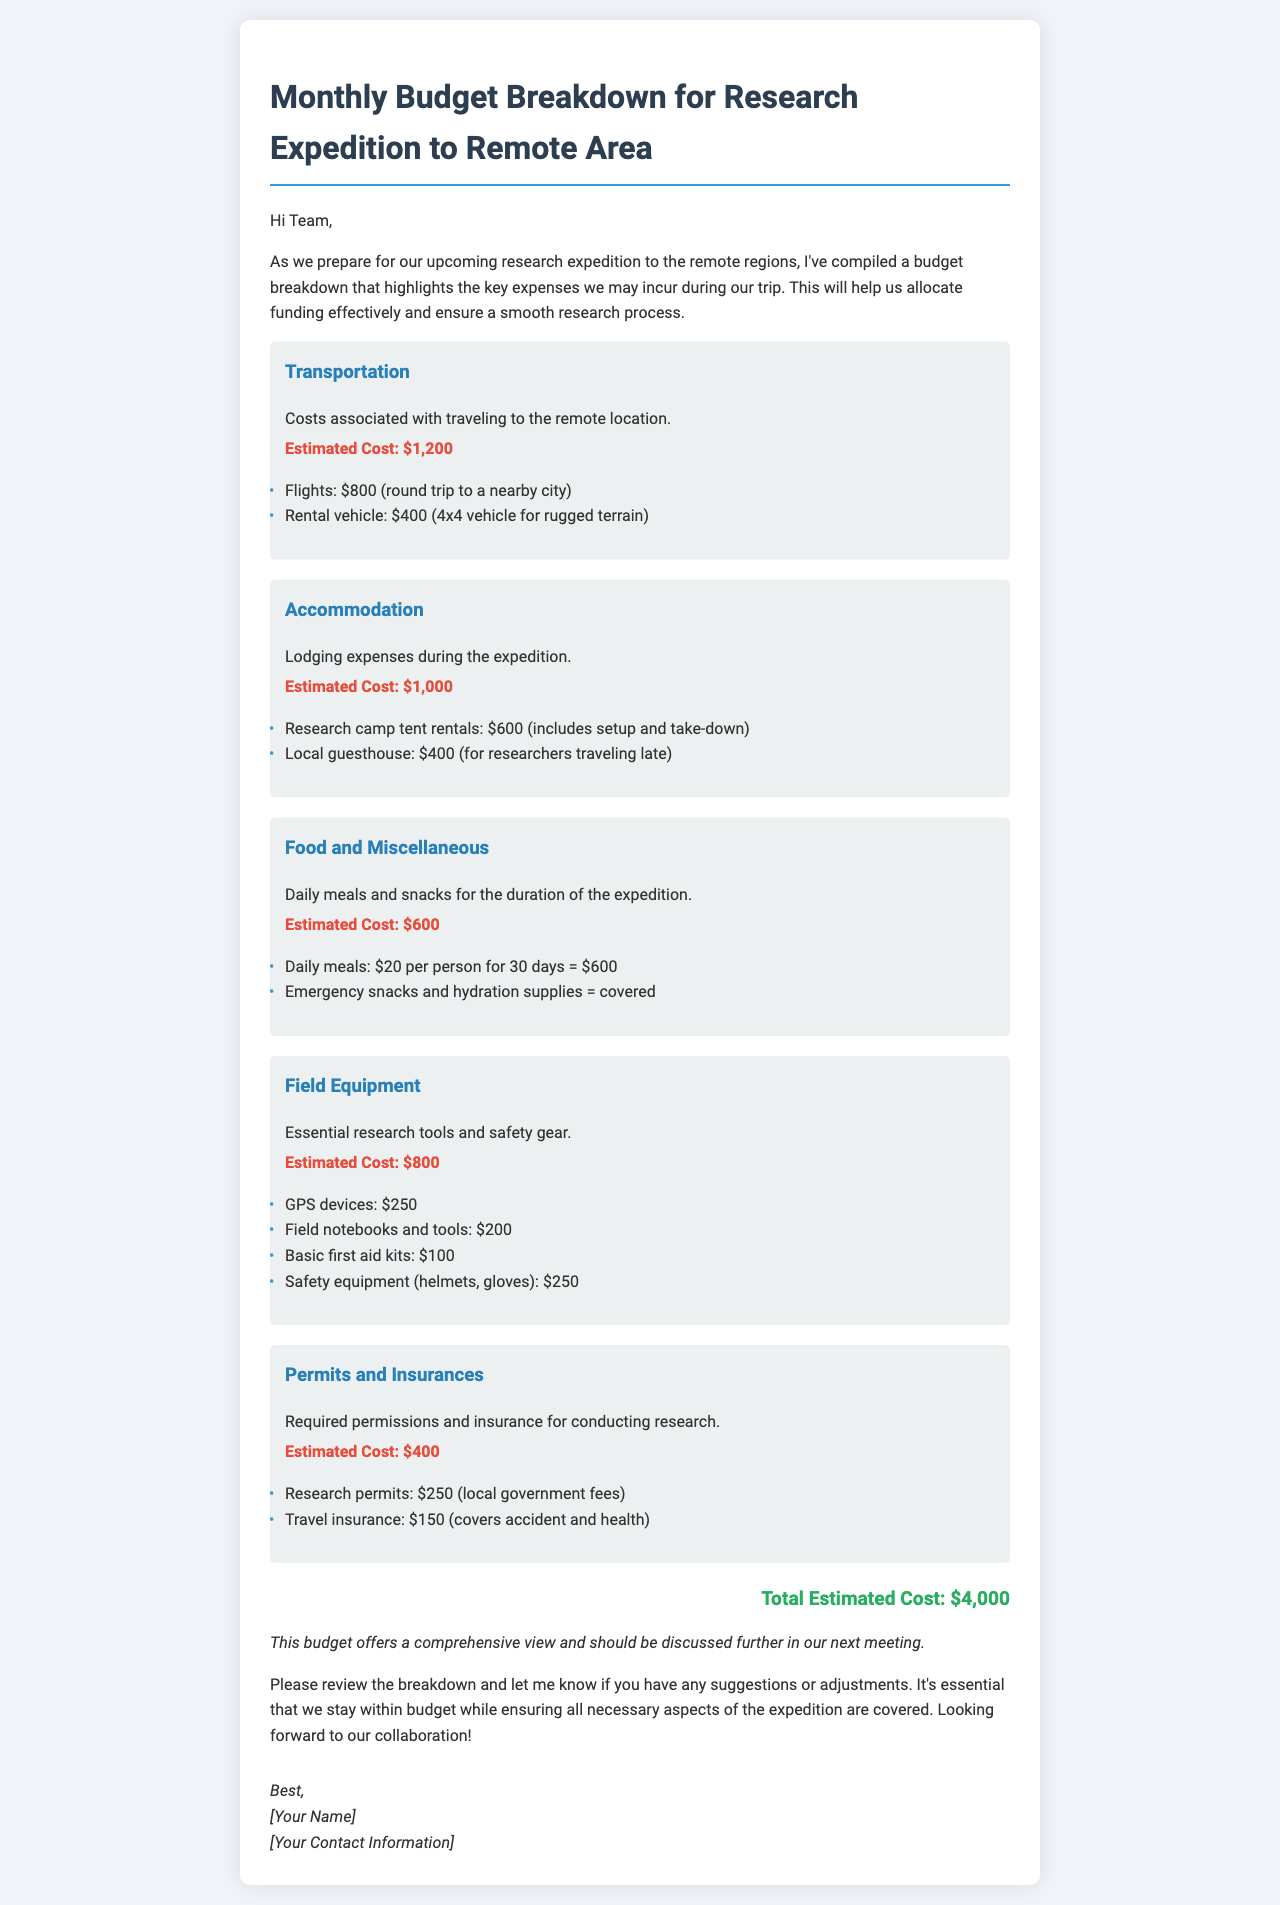What is the estimated cost for transportation? The estimated cost for transportation is provided in the document as $1,200, which includes flights and rental vehicle costs.
Answer: $1,200 How much is allocated for accommodation? The accommodation section specifies the estimated cost of $1,000 for lodging expenses during the expedition.
Answer: $1,000 What is the total estimated cost for the expedition? The document clearly states the total estimated cost at the bottom as $4,000.
Answer: $4,000 What are the two types of expenses mentioned under permits and insurances? The budget breakdown lists research permits and travel insurance as the two types of expenses under permits and insurances.
Answer: Research permits, Travel insurance How much per person is budgeted for daily meals? The document specifies that $20 per person is budgeted for daily meals during the expedition.
Answer: $20 